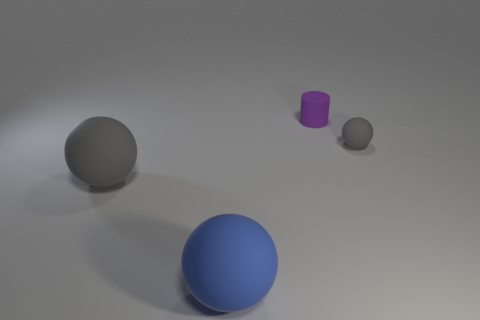Add 2 cyan metallic cylinders. How many objects exist? 6 Subtract all cylinders. How many objects are left? 3 Subtract 0 purple spheres. How many objects are left? 4 Subtract all small cyan rubber balls. Subtract all blue matte balls. How many objects are left? 3 Add 3 tiny gray things. How many tiny gray things are left? 4 Add 2 big brown matte blocks. How many big brown matte blocks exist? 2 